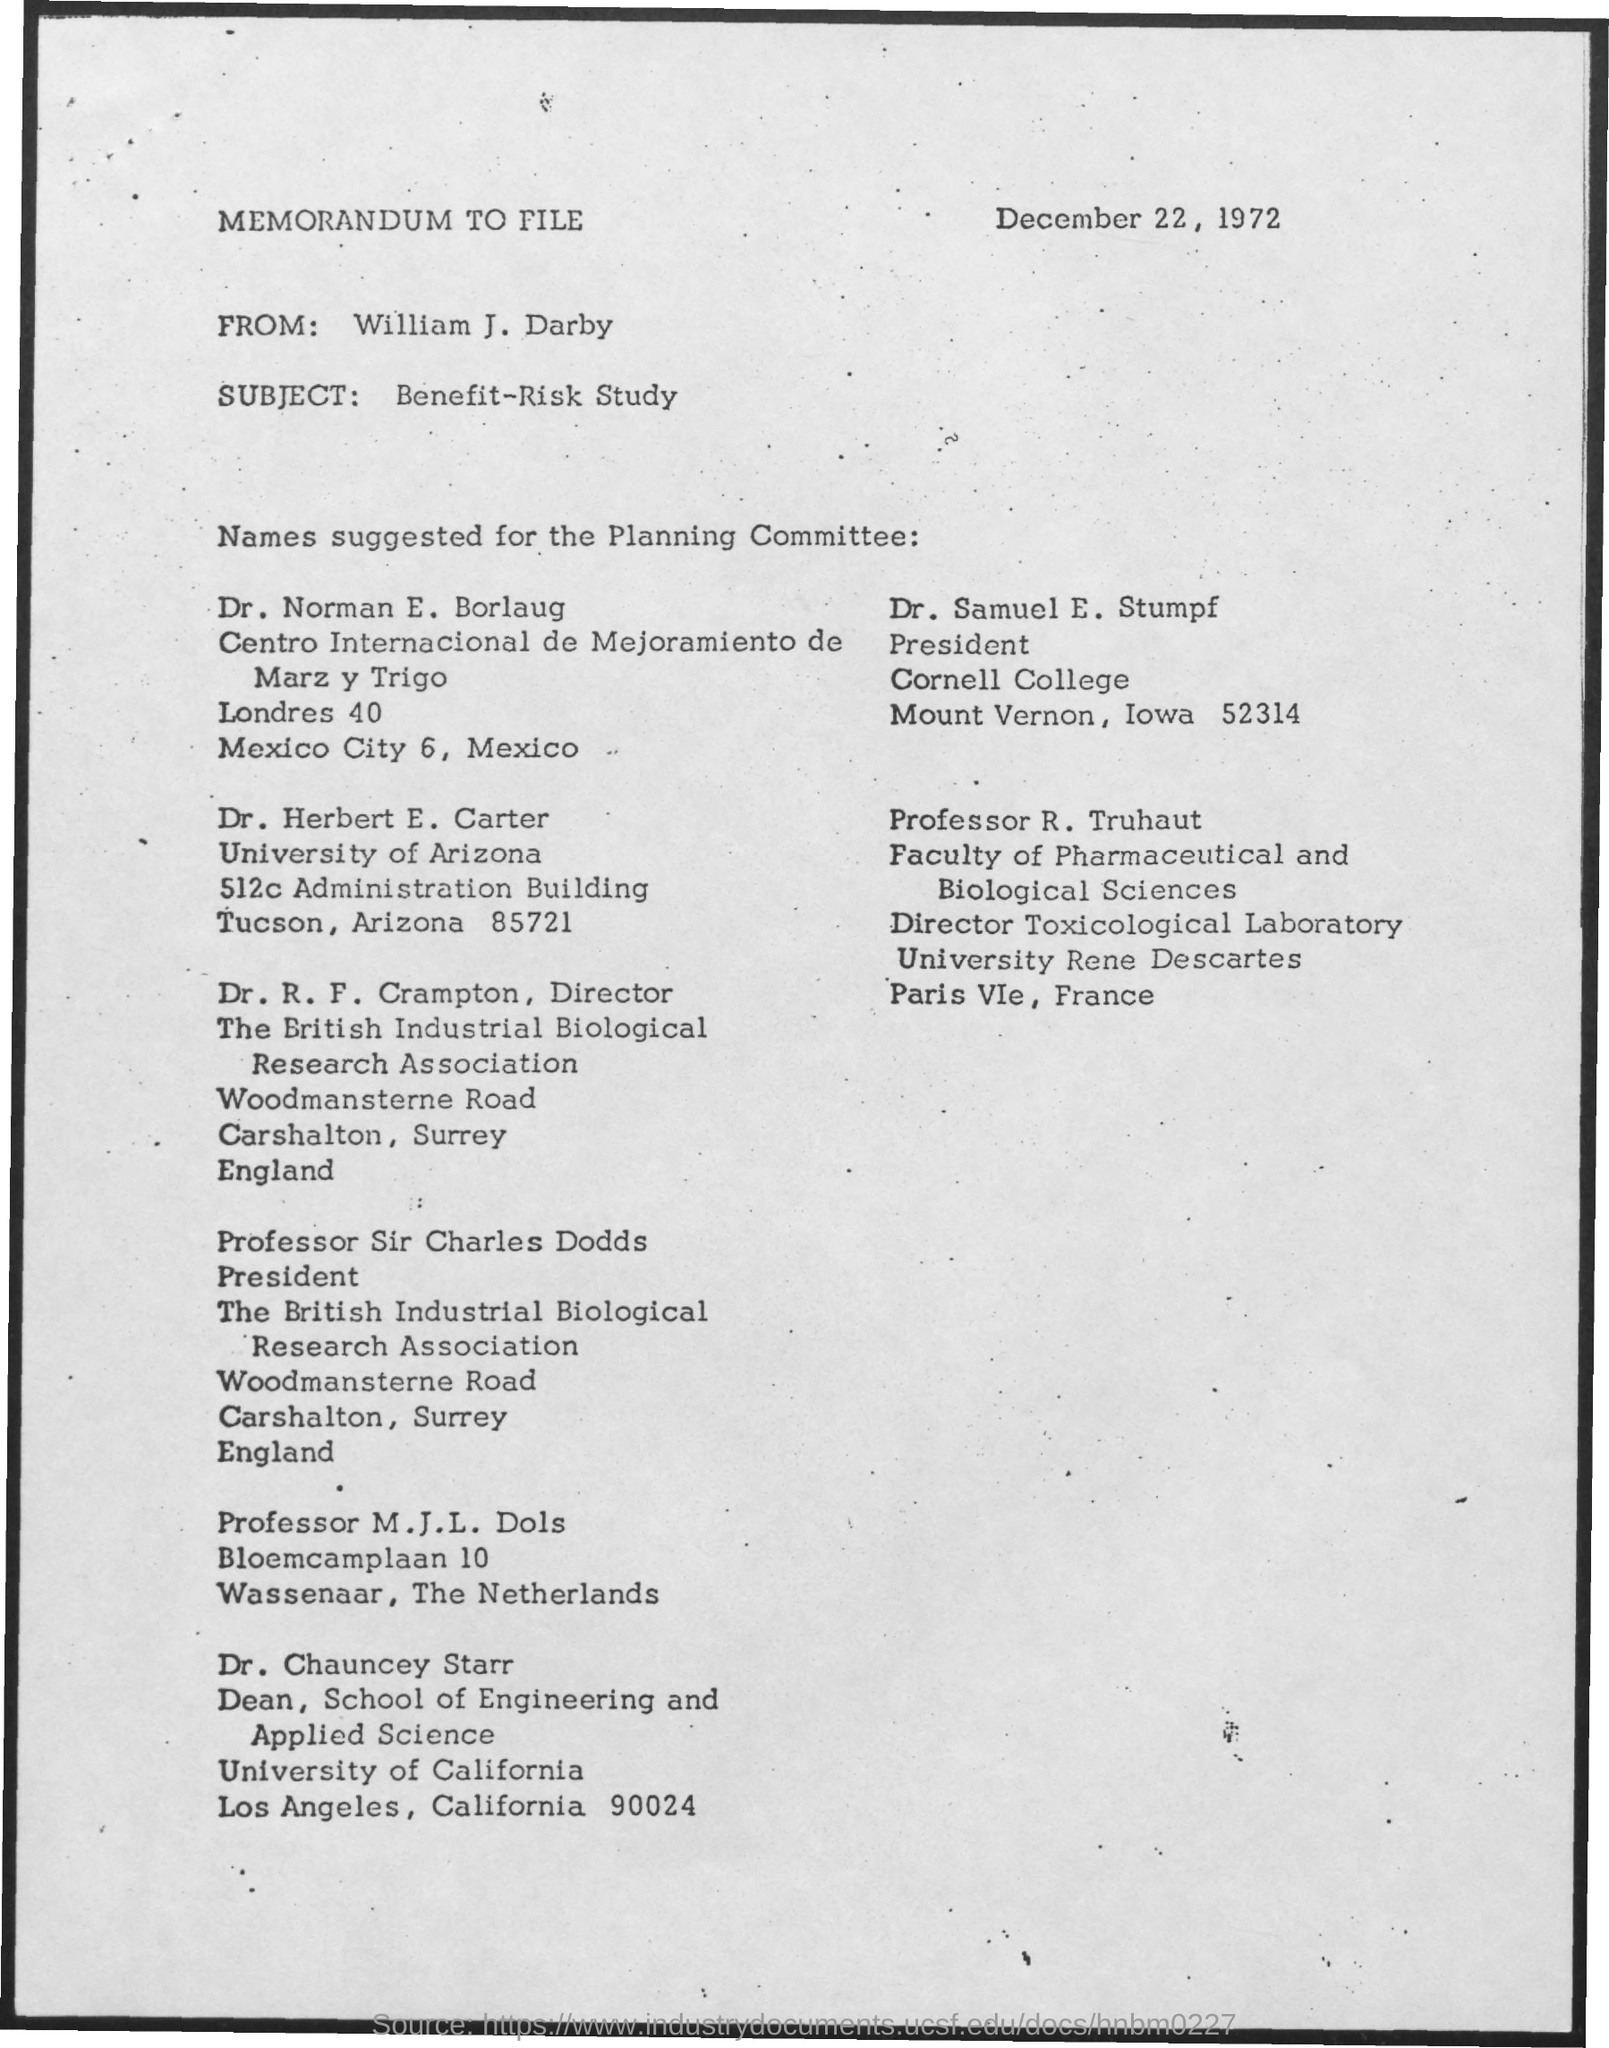What is the date mentioned ?
Give a very brief answer. December 22, 1972. Who is the president of cornell college
Provide a short and direct response. Dr. Samuel E. Stumpf. Where is the cornell college located ?
Offer a very short reply. Mount vernon , Iowa. 